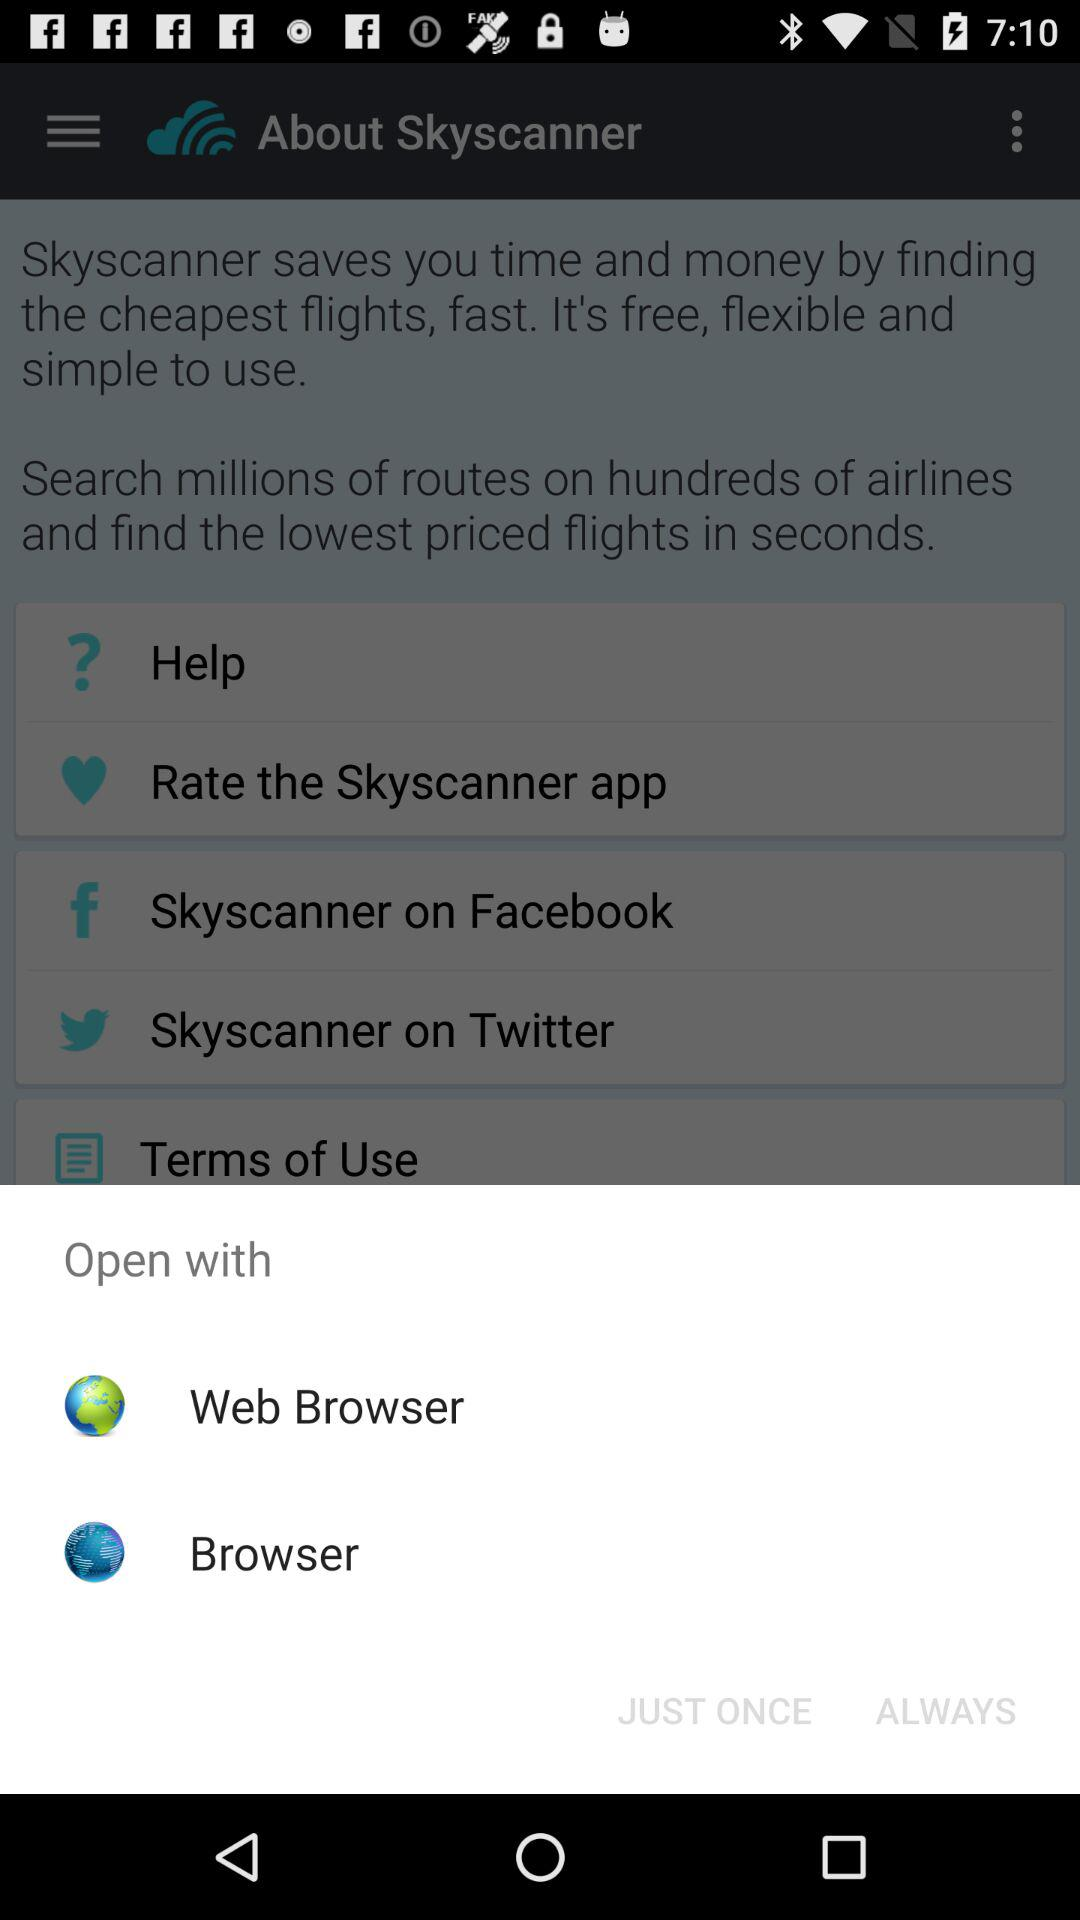How many options are there to open the app?
Answer the question using a single word or phrase. 2 